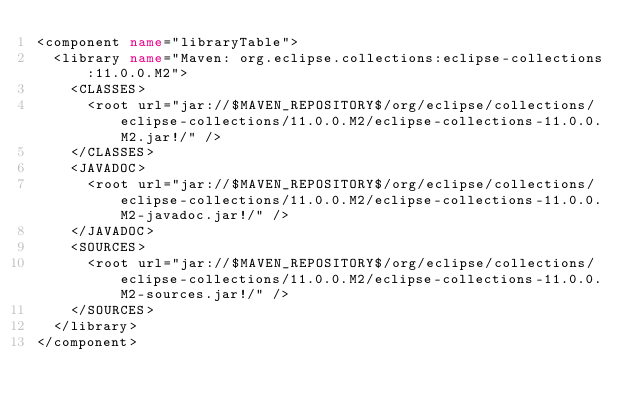Convert code to text. <code><loc_0><loc_0><loc_500><loc_500><_XML_><component name="libraryTable">
  <library name="Maven: org.eclipse.collections:eclipse-collections:11.0.0.M2">
    <CLASSES>
      <root url="jar://$MAVEN_REPOSITORY$/org/eclipse/collections/eclipse-collections/11.0.0.M2/eclipse-collections-11.0.0.M2.jar!/" />
    </CLASSES>
    <JAVADOC>
      <root url="jar://$MAVEN_REPOSITORY$/org/eclipse/collections/eclipse-collections/11.0.0.M2/eclipse-collections-11.0.0.M2-javadoc.jar!/" />
    </JAVADOC>
    <SOURCES>
      <root url="jar://$MAVEN_REPOSITORY$/org/eclipse/collections/eclipse-collections/11.0.0.M2/eclipse-collections-11.0.0.M2-sources.jar!/" />
    </SOURCES>
  </library>
</component></code> 